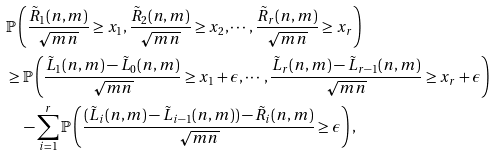Convert formula to latex. <formula><loc_0><loc_0><loc_500><loc_500>& \mathbb { P } \left ( \frac { \tilde { R } _ { 1 } ( n , m ) } { \sqrt { m n } } \geq x _ { 1 } , \frac { \tilde { R } _ { 2 } ( n , m ) } { \sqrt { m n } } \geq x _ { 2 } , \cdots , \frac { \tilde { R } _ { r } ( n , m ) } { \sqrt { m n } } \geq x _ { r } \right ) \\ & \geq \mathbb { P } \left ( \frac { \tilde { L } _ { 1 } ( n , m ) - \tilde { L } _ { 0 } ( n , m ) } { \sqrt { m n } } \geq x _ { 1 } + \epsilon , \cdots , \frac { \tilde { L } _ { r } ( n , m ) - \tilde { L } _ { r - 1 } ( n , m ) } { \sqrt { m n } } \geq x _ { r } + \epsilon \right ) \\ & \quad - \sum _ { i = 1 } ^ { r } \mathbb { P } \left ( \frac { ( \tilde { L } _ { i } ( n , m ) - \tilde { L } _ { i - 1 } ( n , m ) ) - \tilde { R } _ { i } ( n , m ) } { \sqrt { m n } } \geq \epsilon \right ) ,</formula> 